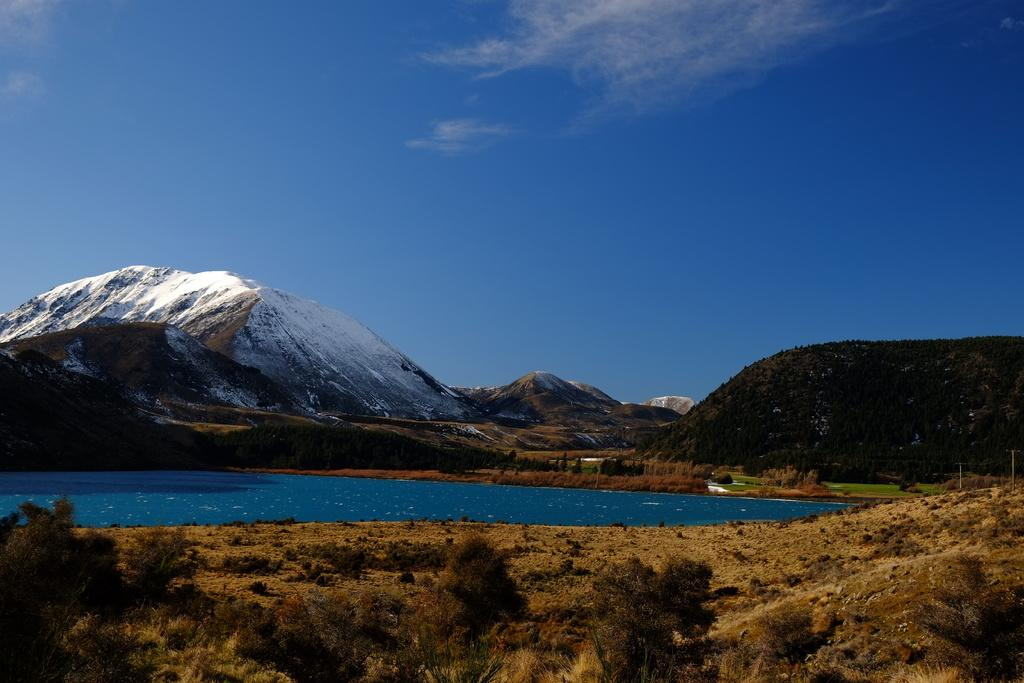What is the main feature in the center of the image? There is a lake in the center of the image. What type of vegetation can be seen at the bottom of the image? There are shrubs at the bottom of the image. What can be seen in the distance in the image? There are hills in the background of the image. What is visible in the sky in the image? The sky is visible in the background of the image. What type of songs can be heard coming from the wrist in the image? There is no wrist or any indication of music in the image. 